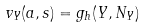Convert formula to latex. <formula><loc_0><loc_0><loc_500><loc_500>v _ { Y } ( a , s ) = g _ { h } ( Y , N _ { Y } )</formula> 